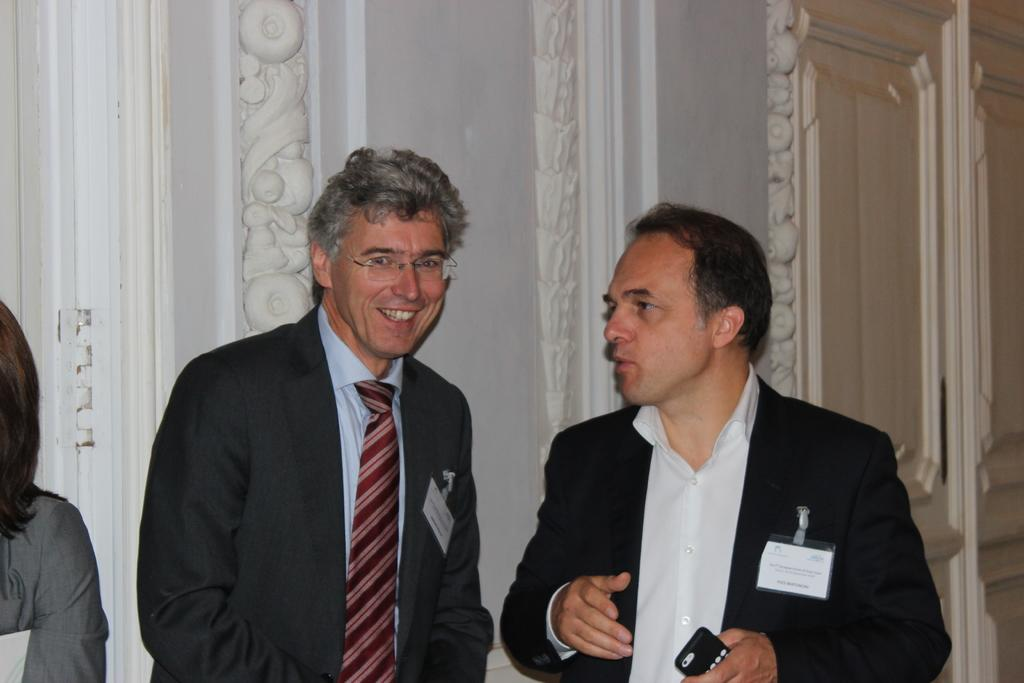How many people are present in the image? There are three people in the image. What is one person doing in the image? One person is holding an object. What can be seen in the background of the image? There is a wall in the background of the image. How many geese are flying in the image? There are no geese present in the image. What type of friend is standing next to the person holding the object? There is no friend mentioned or visible in the image. 